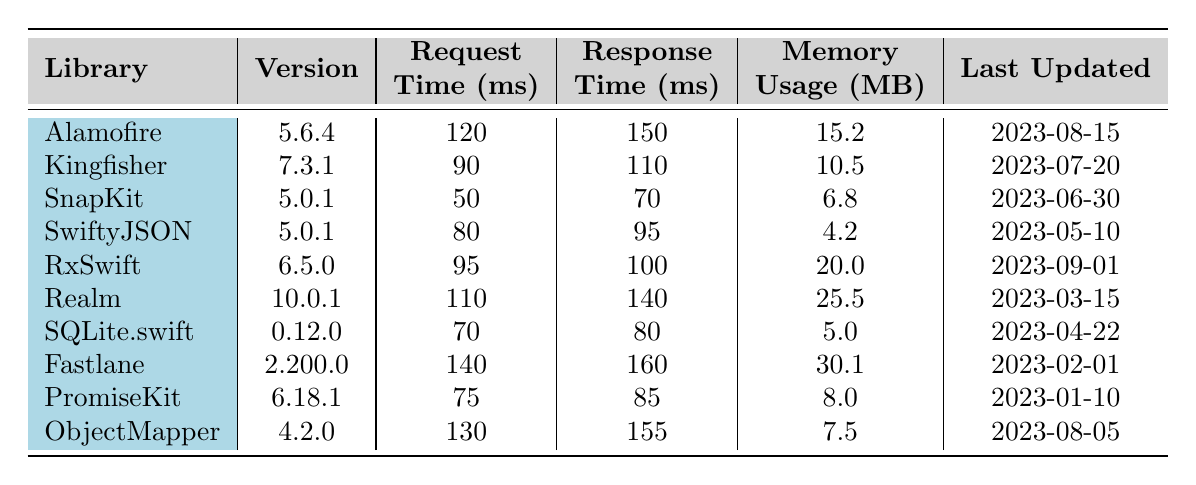What is the request time for Kingfisher? The request time for Kingfisher is specifically listed in the table as 90 milliseconds.
Answer: 90 ms Which library has the highest memory usage? By comparing the memory usage values in the table, Fastlane shows the highest memory usage at 30.1 MB.
Answer: Fastlane What is the response time of SnapKit? The response time for SnapKit is directly provided in the table as 70 milliseconds.
Answer: 70 ms How much faster is the request time of SnapKit compared to Alamofire? SnapKit’s request time is 50 ms, and Alamofire’s is 120 ms. The difference is 120 - 50 = 70 ms.
Answer: 70 ms Is the last updated date for ObjectMapper newer than that of PromiseKit? ObjectMapper was last updated on 2023-08-05, and PromiseKit was last updated on 2023-01-10. Since August 5 is after January 10, the statement is true.
Answer: Yes What is the average request time of the libraries listed? The sum of the request times is 120 + 90 + 50 + 80 + 95 + 110 + 70 + 140 + 75 + 130 = 1,050 ms. There are 10 libraries, so the average is 1,050 ms / 10 = 105 ms.
Answer: 105 ms Which library has a better response time, RxSwift or Fastlane? RxSwift has a response time of 100 ms, while Fastlane has a response time of 160 ms. Since 100 ms is less than 160 ms, RxSwift is better in this case.
Answer: RxSwift What is the total memory usage of the three libraries that were last updated most recently? The libraries that were last updated most recently are RxSwift (20.0 MB), Alamofire (15.2 MB), and ObjectMapper (7.5 MB). The total memory usage is 20.0 + 15.2 + 7.5 = 42.7 MB.
Answer: 42.7 MB How does the request time of Realm compare to that of SQLite.swift? Realm’s request time is 110 ms, and SQLite.swift’s is 70 ms. Since 110 ms is greater than 70 ms, Realm has a longer request time.
Answer: Longer Which library has the fastest response time overall? By comparing all response times, SnapKit has the fastest response time at 70 ms, which is the lowest in the table.
Answer: SnapKit 